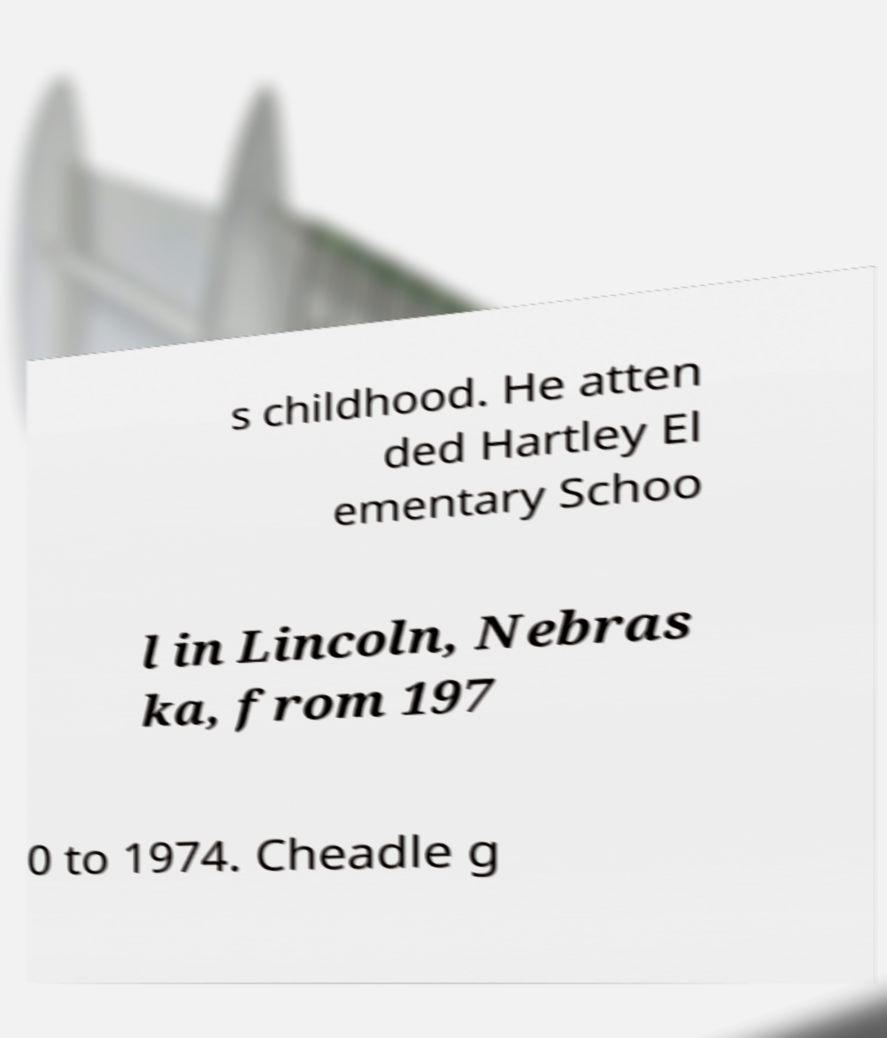Please read and relay the text visible in this image. What does it say? s childhood. He atten ded Hartley El ementary Schoo l in Lincoln, Nebras ka, from 197 0 to 1974. Cheadle g 